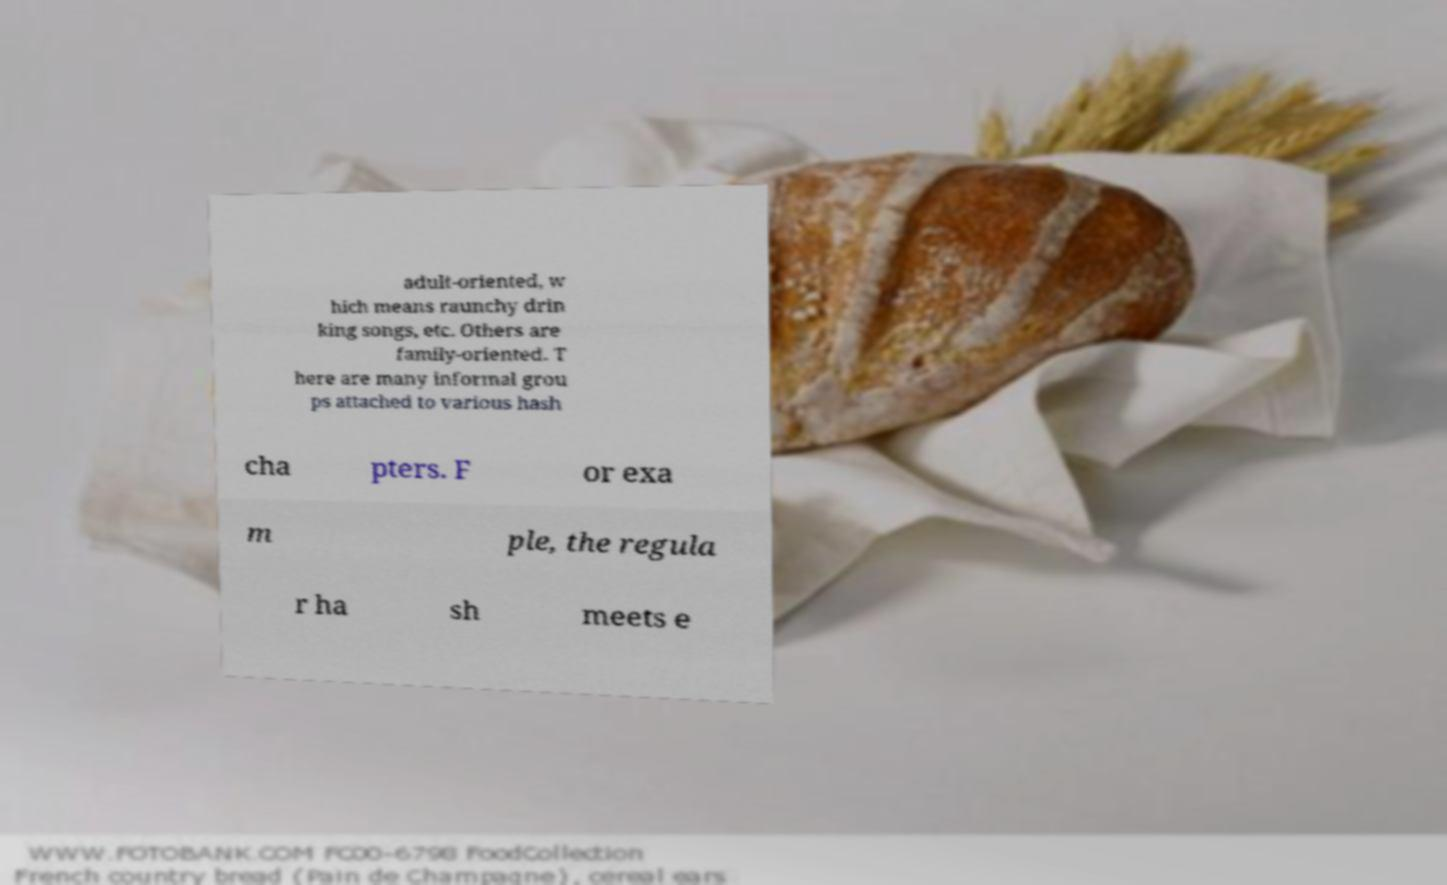Please identify and transcribe the text found in this image. adult-oriented, w hich means raunchy drin king songs, etc. Others are family-oriented. T here are many informal grou ps attached to various hash cha pters. F or exa m ple, the regula r ha sh meets e 